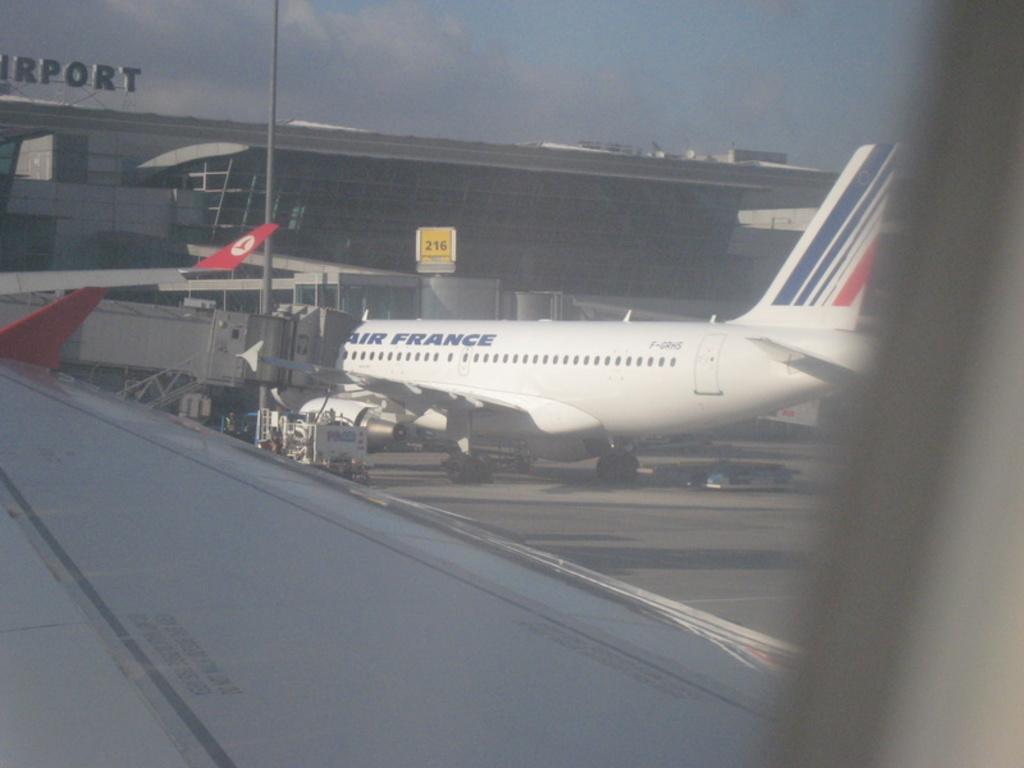What can be seen on the ground in the image? There are airplanes on the ground in the image. What type of structure is present in the image? There is a building in the image. What object can be seen standing upright in the image? There is a pole in the image. What is visible in the background of the image? The sky is visible in the background of the image. What can be observed in the sky in the image? Clouds are present in the sky. Can you tell me how many cows are grazing in the image? There are no cows present in the image; it features airplanes on the ground, a building, a pole, and a sky with clouds. What type of drink is being served in the image? There is no drink present in the image, so it cannot be determined what might be served. 